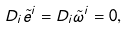<formula> <loc_0><loc_0><loc_500><loc_500>D _ { i } \tilde { e } ^ { i } = D _ { i } \tilde { \omega } ^ { i } = 0 ,</formula> 